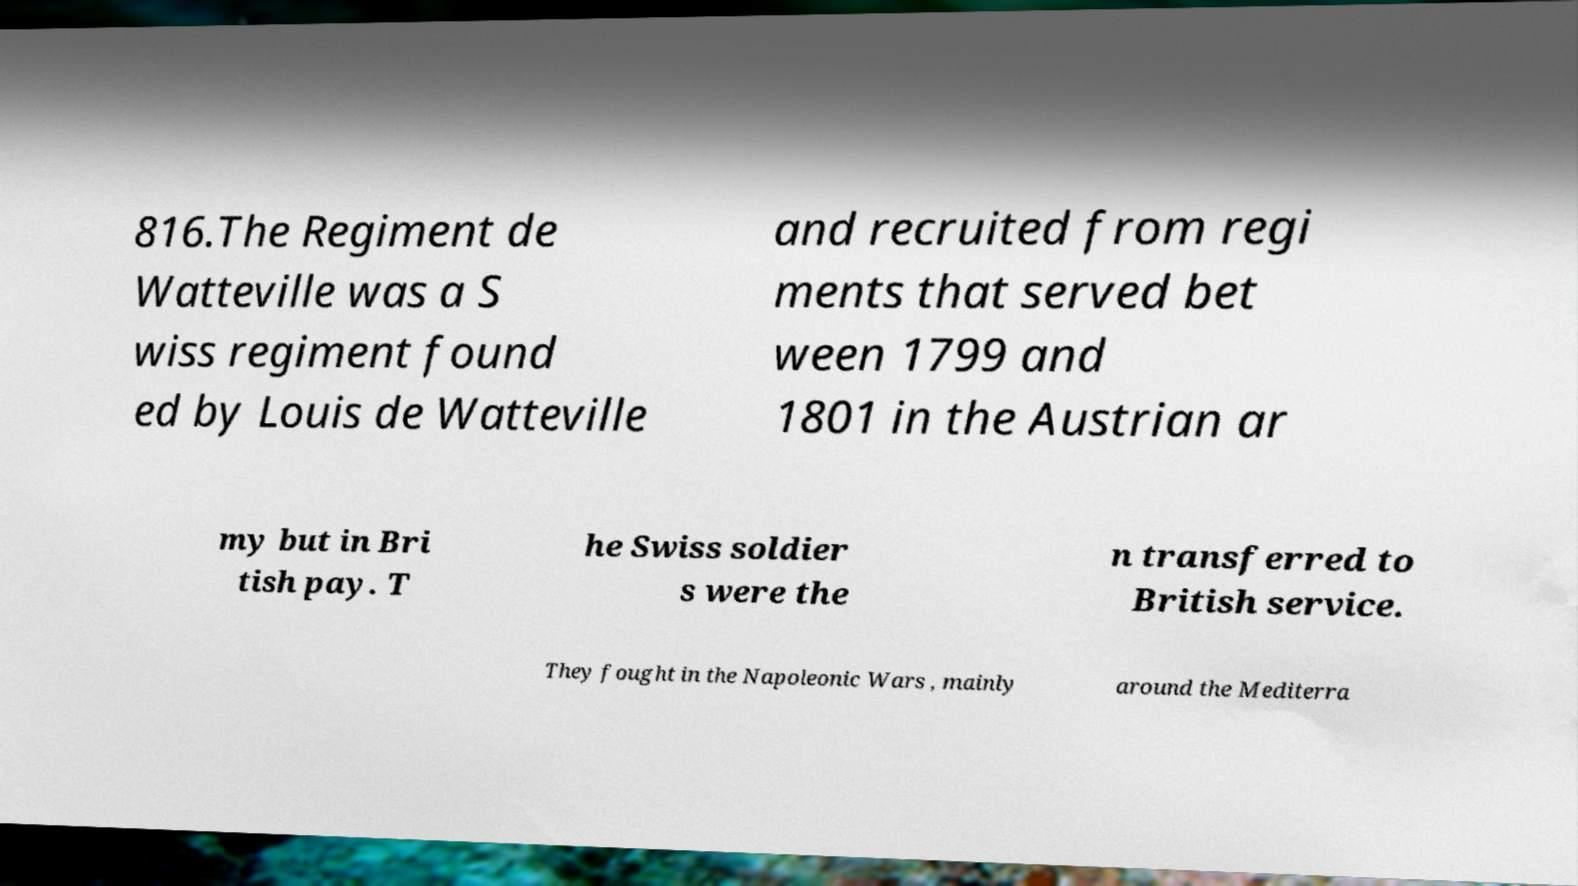Could you assist in decoding the text presented in this image and type it out clearly? 816.The Regiment de Watteville was a S wiss regiment found ed by Louis de Watteville and recruited from regi ments that served bet ween 1799 and 1801 in the Austrian ar my but in Bri tish pay. T he Swiss soldier s were the n transferred to British service. They fought in the Napoleonic Wars , mainly around the Mediterra 